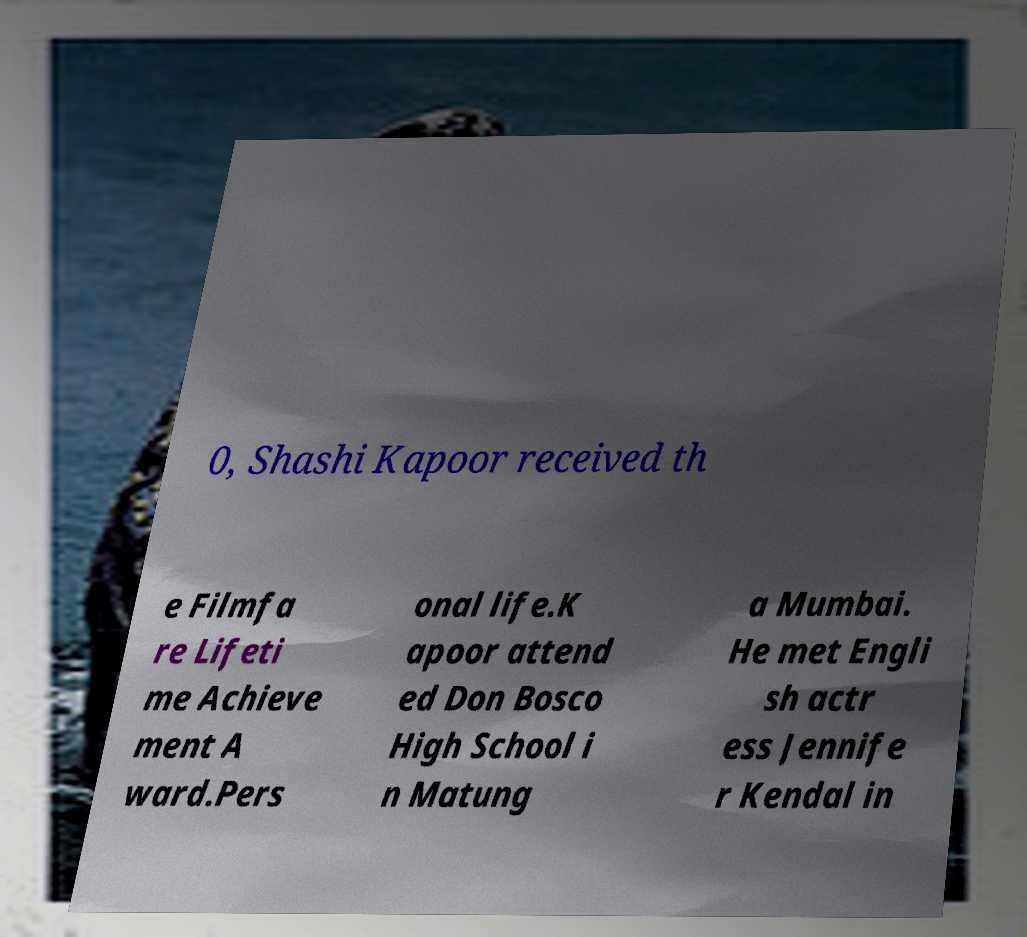Could you extract and type out the text from this image? 0, Shashi Kapoor received th e Filmfa re Lifeti me Achieve ment A ward.Pers onal life.K apoor attend ed Don Bosco High School i n Matung a Mumbai. He met Engli sh actr ess Jennife r Kendal in 